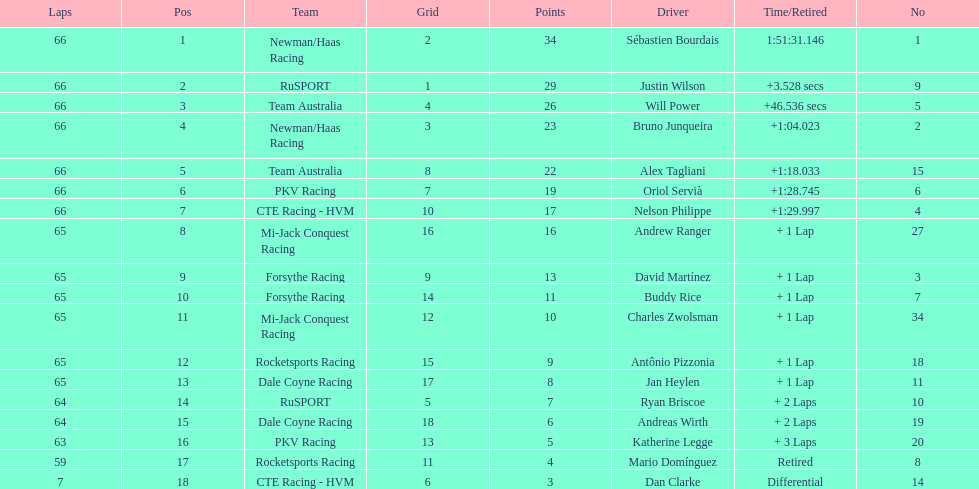Rice finished 10th. who finished next? Charles Zwolsman. 